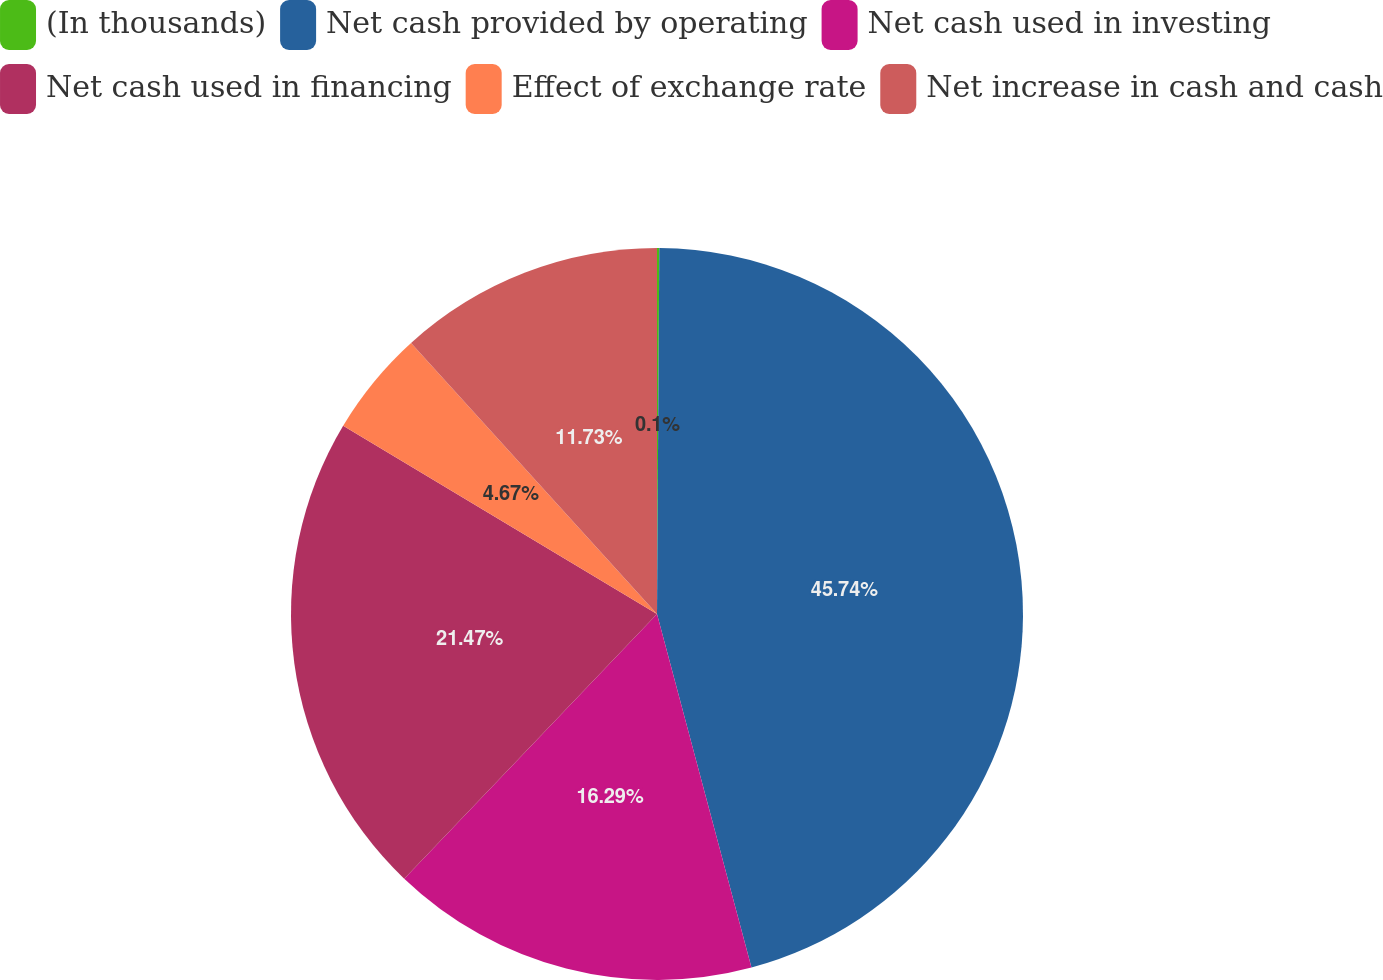Convert chart to OTSL. <chart><loc_0><loc_0><loc_500><loc_500><pie_chart><fcel>(In thousands)<fcel>Net cash provided by operating<fcel>Net cash used in investing<fcel>Net cash used in financing<fcel>Effect of exchange rate<fcel>Net increase in cash and cash<nl><fcel>0.1%<fcel>45.75%<fcel>16.29%<fcel>21.47%<fcel>4.67%<fcel>11.73%<nl></chart> 